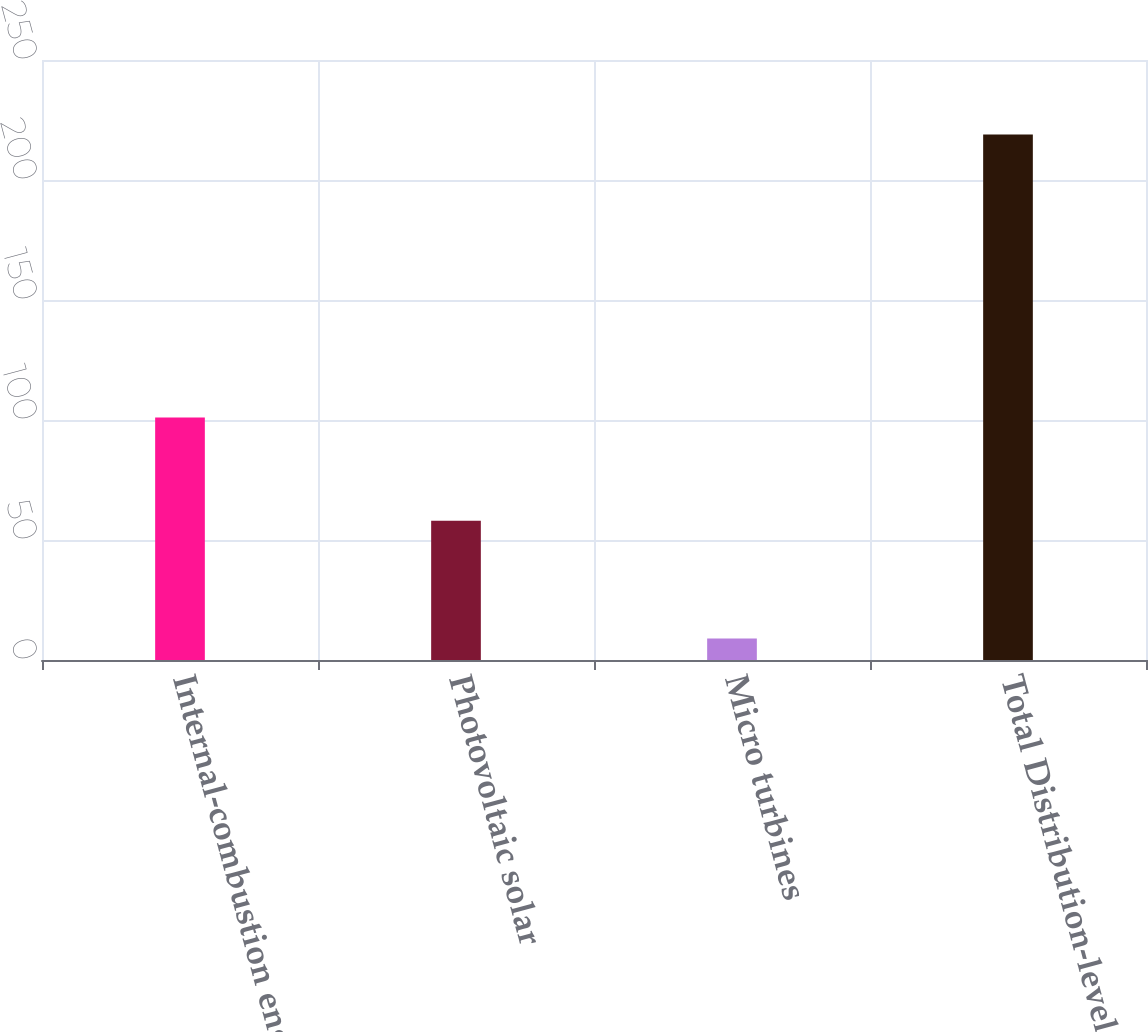<chart> <loc_0><loc_0><loc_500><loc_500><bar_chart><fcel>Internal-combustion engines<fcel>Photovoltaic solar<fcel>Micro turbines<fcel>Total Distribution-level<nl><fcel>101<fcel>58<fcel>9<fcel>219<nl></chart> 